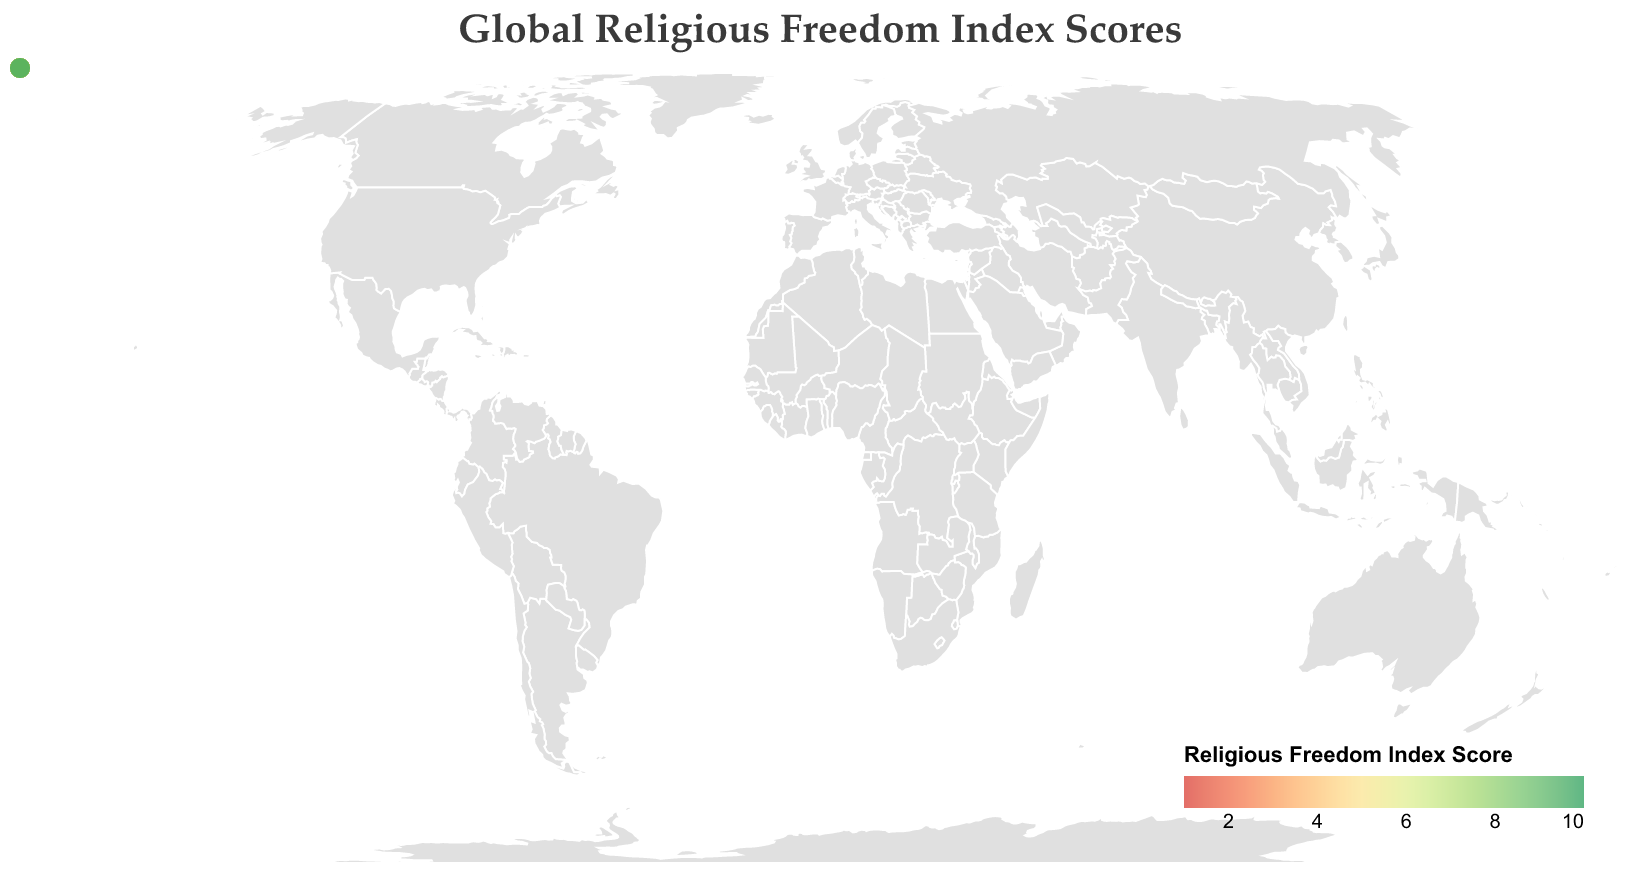What is the general topic of this figure? The title of the figure, "Global Religious Freedom Index Scores," indicates that the data presents religious freedom scores globally by country.
Answer: Global Religious Freedom Index Scores Which country has the highest Religious Freedom Index Score? By observing the plot, Vatican City has the highest score, indicated by the highest number, 9.5.
Answer: Vatican City What color represents countries with low Religious Freedom Index Scores? The color for low scores ranges from deep red to lighter orange, visible in countries like Iran and China.
Answer: Deep red to lighter orange How does the religious freedom in China compare to Australia? China's score is 1.8 (low) shown by a red color, while Australia has a high score of 8.5 shown by a green color. Australia enjoys much more religious freedom compared to China.
Answer: Australia has much more religious freedom What is the average Religious Freedom Index Score of United States, Canada, and Germany? Summing the scores of the United States (8.2), Canada (8.7), and Germany (8.1) gives a total of 25. Then, dividing by 3, the average is approximately 8.3.
Answer: 8.3 Which countries have a Religious Freedom Index Score below 2.0? Observing the countries with scores below 2.0, we find China (1.8) and Iran (1.5) fitting this criterion.
Answer: China and Iran How does the religious freedom in Brazil compare to Japan? Both Brazil (7.9) and Japan (7.8) have very similar scores, as indicated by their close values and the nearly same color shade in the figure.
Answer: Very similar What descriptive attribute is found on the circles? The circles have a tooltip feature that provides information about the country and its Religious Freedom Index Score when hovered over on the figure.
Answer: Tooltip with country and score Which region appears to have the most countries with high Religious Freedom Index Scores? Observing the figure, many high scores, represented by green colors, are found in regions like North America and Western Europe (USA, Canada, Germany, etc.).
Answer: North America and Western Europe What is the range of the Religious Freedom Index Score? The scores in the figure range between the lowest score of 1.5 (Iran) and the highest score of 9.5 (Vatican City).
Answer: 1.5 to 9.5 